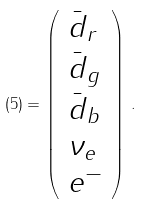<formula> <loc_0><loc_0><loc_500><loc_500>( 5 ) = \left ( \begin{array} { l } \bar { d } _ { r } \\ \bar { d } _ { g } \\ \bar { d } _ { b } \\ \nu _ { e } \\ e ^ { - } \end{array} \right ) \, .</formula> 